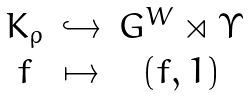Convert formula to latex. <formula><loc_0><loc_0><loc_500><loc_500>\begin{array} { c c c } K _ { \rho } & \hookrightarrow & G ^ { W } \rtimes \Upsilon \\ f & \mapsto & ( f , 1 ) \end{array}</formula> 